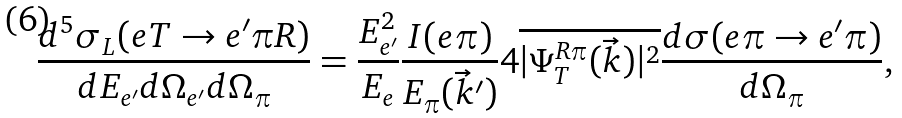Convert formula to latex. <formula><loc_0><loc_0><loc_500><loc_500>\frac { d ^ { 5 } \sigma _ { L } ( e T \to e ^ { \prime } \pi R ) } { d E _ { e ^ { \prime } } d \Omega _ { e ^ { \prime } } d \Omega _ { \pi } } = \frac { E _ { e ^ { \prime } } ^ { 2 } } { E _ { e } } \frac { I ( e \pi ) } { E _ { \pi } ( \vec { k } ^ { \prime } ) } 4 \overline { | \Psi ^ { R \pi } _ { T } ( \vec { k } ) | ^ { 2 } } \frac { d \sigma ( e \pi \to e ^ { \prime } \pi ) } { d \Omega _ { \pi } } ,</formula> 